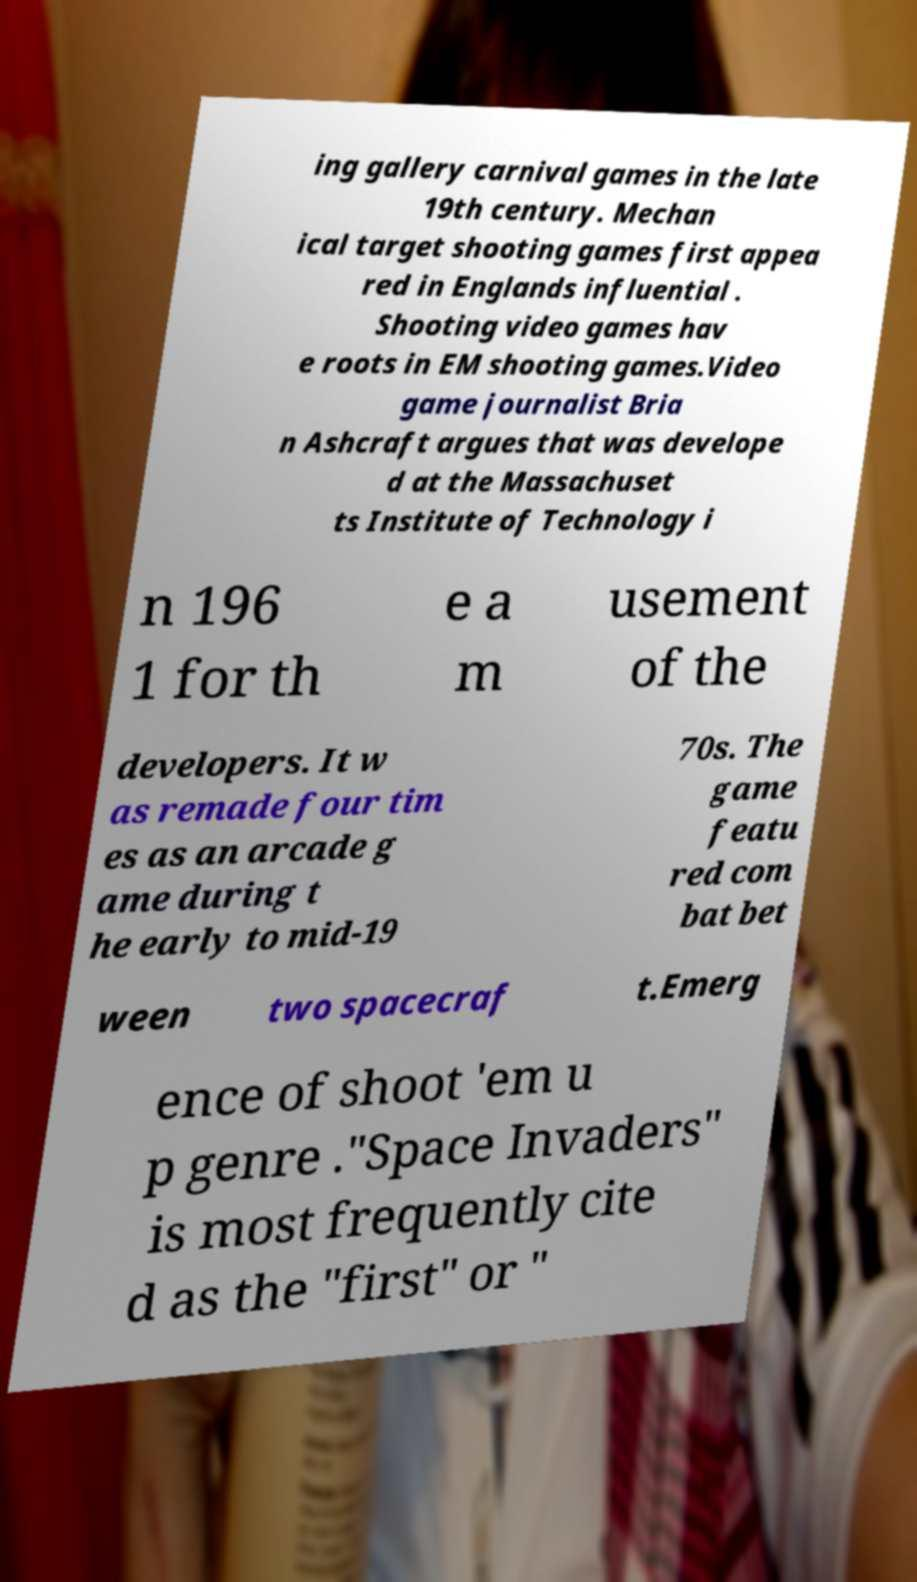For documentation purposes, I need the text within this image transcribed. Could you provide that? ing gallery carnival games in the late 19th century. Mechan ical target shooting games first appea red in Englands influential . Shooting video games hav e roots in EM shooting games.Video game journalist Bria n Ashcraft argues that was develope d at the Massachuset ts Institute of Technology i n 196 1 for th e a m usement of the developers. It w as remade four tim es as an arcade g ame during t he early to mid-19 70s. The game featu red com bat bet ween two spacecraf t.Emerg ence of shoot 'em u p genre ."Space Invaders" is most frequently cite d as the "first" or " 